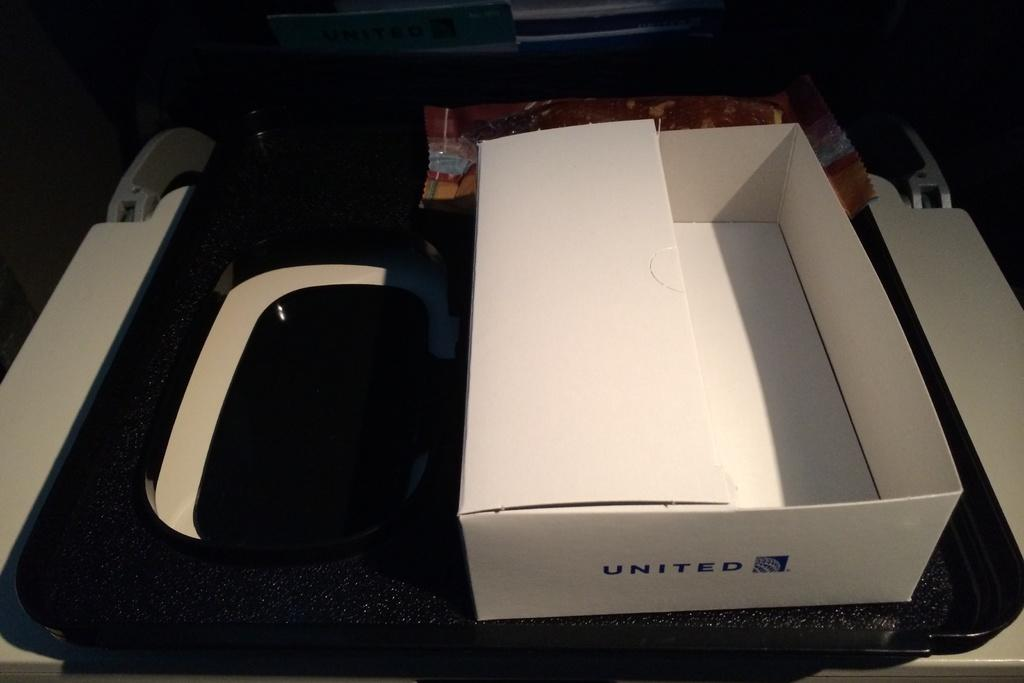<image>
Offer a succinct explanation of the picture presented. An empty United Airlines box sits ontop of a tray table 